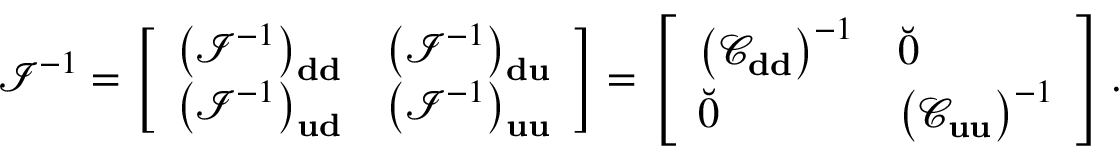Convert formula to latex. <formula><loc_0><loc_0><loc_500><loc_500>\mathcal { I } ^ { - 1 } = \left [ \begin{array} { l l } { \left ( \mathcal { I } ^ { - 1 } \right ) _ { d d } } & { \left ( \mathcal { I } ^ { - 1 } \right ) _ { d u } } \\ { \left ( \mathcal { I } ^ { - 1 } \right ) _ { u d } } & { \left ( \mathcal { I } ^ { - 1 } \right ) _ { u u } } \end{array} \right ] = \left [ \begin{array} { l l } { \left ( \mathcal { C } _ { d d } \right ) ^ { - 1 } } & { \breve { 0 } } \\ { \breve { 0 } } & { \left ( \mathcal { C } _ { u u } \right ) ^ { - 1 } } \end{array} \right ] .</formula> 